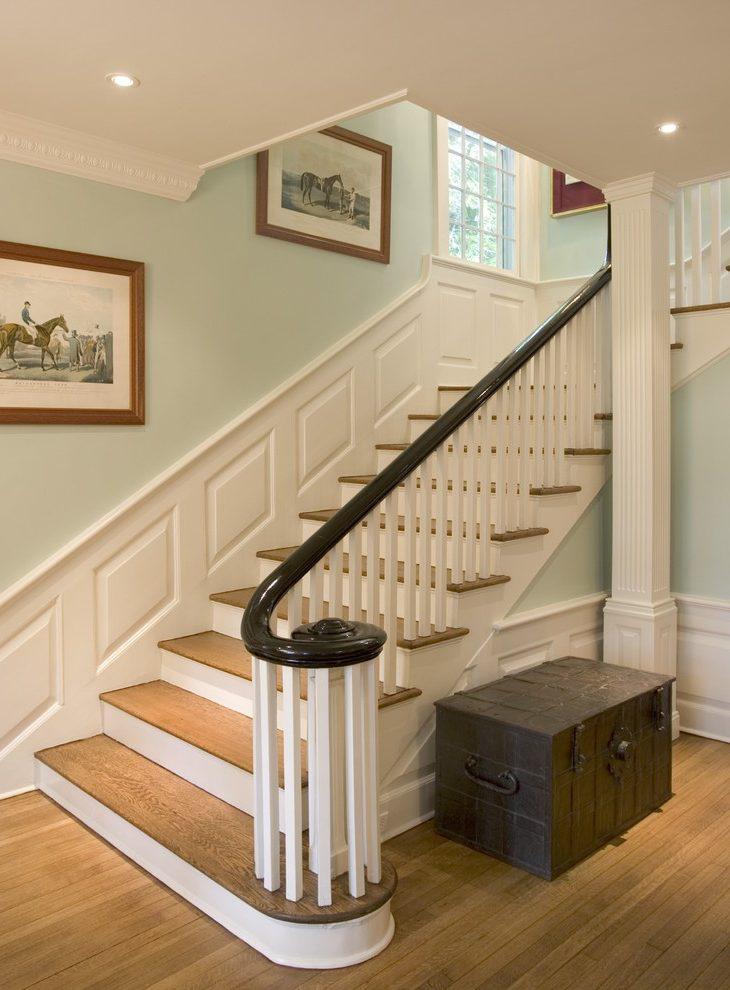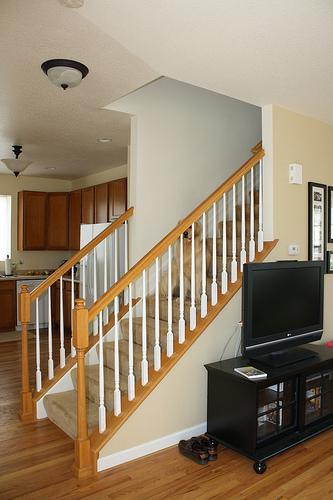The first image is the image on the left, the second image is the image on the right. Examine the images to the left and right. Is the description "In at least one of the images, the piece of furniture near the bottom of the stairs has a vase of flowers on it." accurate? Answer yes or no. No. The first image is the image on the left, the second image is the image on the right. Examine the images to the left and right. Is the description "Framed pictures follow the line of the stairway in the image on the right." accurate? Answer yes or no. No. 